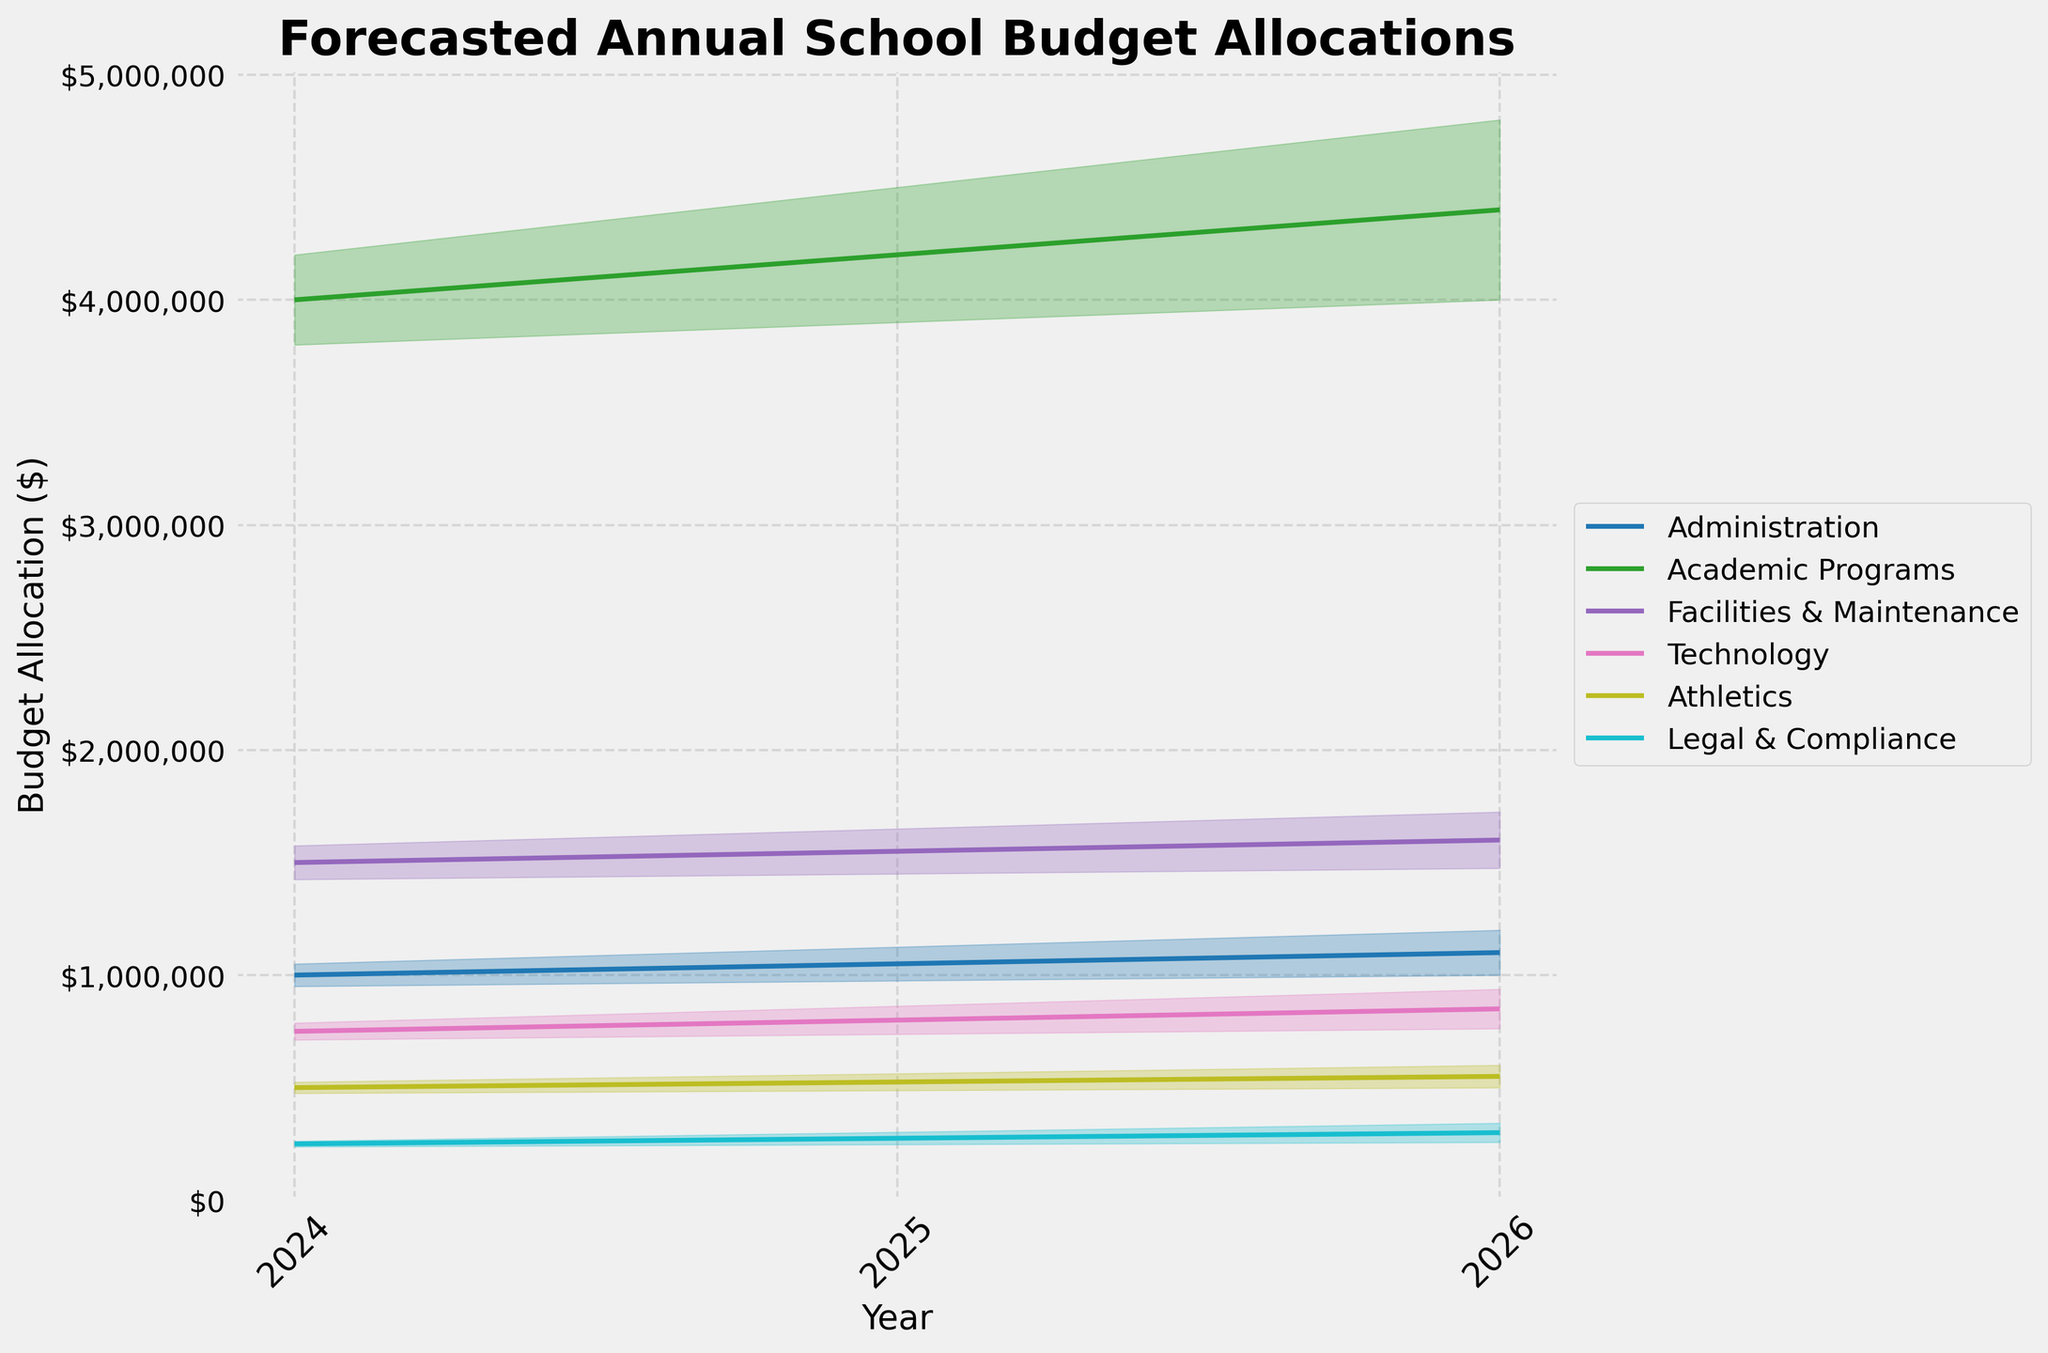What's the title of the figure? The title is prominently displayed at the top of the figure.
Answer: Forecasted Annual School Budget Allocations How does the budget forecast for 'Technology' change from 2024 to 2026? Look at the forecast values for the 'Technology' department from 2024 to 2026. In 2024, it is $750,000; in 2025, it is $800,000; and in 2026, it is $850,000.
Answer: It increases What is the confidence interval range for 'Legal & Compliance' in 2025? Examine the 'Low_CI' and 'High_CI' values for 'Legal & Compliance' in 2025. The values are $247,500 and $302,500, respectively. Subtract the low value from the high value: $302,500 - $247,500 = $55,000.
Answer: $55,000 Which department has the highest budget allocation forecast in 2024? Check the forecast values for all departments in 2024. Compare these values to find the highest one. 'Academic Programs' has a forecast of $4,000,000, which is the highest.
Answer: Academic Programs Between 'Athletics' and 'Technology', which department has a smaller confidence interval range in 2026? Calculate the confidence interval ranges for both departments in 2026. 'Athletics' has a range of ($525,000 - 475,000) = $125,000. 'Technology' has a range of ($937,500 - 762,500) = $175,000.
Answer: Athletics What is the percentage increase in the forecast for 'Administration' from 2024 to 2026? Calculate the forecast values for 'Administration' in 2024 and 2026. The values are $1,000,000 and $1,100,000. The percentage increase is ((1,100,000 - 1,000,000) / 1,000,000) * 100 = 10%.
Answer: 10% Compare the forecasted budget for 'Facilities & Maintenance' and 'Academic Programs' in 2025. Which one is larger, and by how much? Look at the forecast values for both departments in 2025. 'Facilities & Maintenance' has a forecast of $1,550,000, and 'Academic Programs' has a forecast of $4,200,000. The difference is $4,200,000 - $1,550,000 = $2,650,000.
Answer: Academic Programs by $2,650,000 What trend can be observed for the budget allocation under 'Legal & Compliance' from 2024 to 2026? Observe the forecast values for 'Legal & Compliance' over the years. The values are $250,000 in 2024, $275,000 in 2025, and $300,000 in 2026.
Answer: It shows an increasing trend For which year is the forecasted budget for 'Academic Programs' expected to be closest to $4,200,000? Compare forecast values for 'Academic Programs' with $4,200,000 value. In 2025, the forecast is exactly $4,200,000.
Answer: 2025 